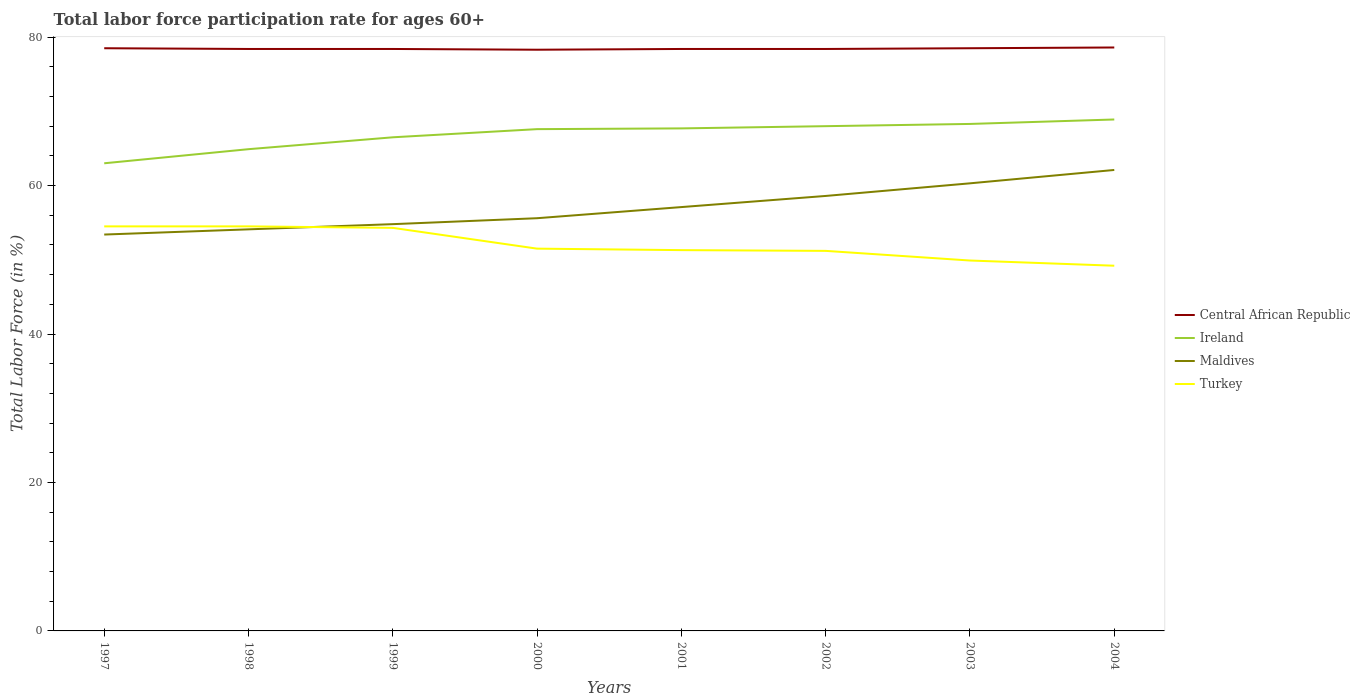How many different coloured lines are there?
Keep it short and to the point. 4. Does the line corresponding to Maldives intersect with the line corresponding to Ireland?
Ensure brevity in your answer.  No. Across all years, what is the maximum labor force participation rate in Ireland?
Your answer should be compact. 63. What is the total labor force participation rate in Ireland in the graph?
Your answer should be compact. -2.7. What is the difference between the highest and the second highest labor force participation rate in Ireland?
Offer a terse response. 5.9. How many years are there in the graph?
Ensure brevity in your answer.  8. What is the difference between two consecutive major ticks on the Y-axis?
Your response must be concise. 20. Are the values on the major ticks of Y-axis written in scientific E-notation?
Make the answer very short. No. Does the graph contain any zero values?
Keep it short and to the point. No. Where does the legend appear in the graph?
Your answer should be very brief. Center right. How many legend labels are there?
Your answer should be very brief. 4. How are the legend labels stacked?
Offer a terse response. Vertical. What is the title of the graph?
Your response must be concise. Total labor force participation rate for ages 60+. Does "Iran" appear as one of the legend labels in the graph?
Provide a succinct answer. No. What is the Total Labor Force (in %) of Central African Republic in 1997?
Give a very brief answer. 78.5. What is the Total Labor Force (in %) in Maldives in 1997?
Keep it short and to the point. 53.4. What is the Total Labor Force (in %) of Turkey in 1997?
Make the answer very short. 54.5. What is the Total Labor Force (in %) of Central African Republic in 1998?
Offer a terse response. 78.4. What is the Total Labor Force (in %) in Ireland in 1998?
Offer a terse response. 64.9. What is the Total Labor Force (in %) of Maldives in 1998?
Your answer should be compact. 54.1. What is the Total Labor Force (in %) of Turkey in 1998?
Keep it short and to the point. 54.5. What is the Total Labor Force (in %) of Central African Republic in 1999?
Keep it short and to the point. 78.4. What is the Total Labor Force (in %) of Ireland in 1999?
Make the answer very short. 66.5. What is the Total Labor Force (in %) of Maldives in 1999?
Give a very brief answer. 54.8. What is the Total Labor Force (in %) of Turkey in 1999?
Your answer should be compact. 54.3. What is the Total Labor Force (in %) of Central African Republic in 2000?
Provide a succinct answer. 78.3. What is the Total Labor Force (in %) in Ireland in 2000?
Offer a very short reply. 67.6. What is the Total Labor Force (in %) in Maldives in 2000?
Ensure brevity in your answer.  55.6. What is the Total Labor Force (in %) of Turkey in 2000?
Give a very brief answer. 51.5. What is the Total Labor Force (in %) in Central African Republic in 2001?
Keep it short and to the point. 78.4. What is the Total Labor Force (in %) in Ireland in 2001?
Make the answer very short. 67.7. What is the Total Labor Force (in %) of Maldives in 2001?
Give a very brief answer. 57.1. What is the Total Labor Force (in %) in Turkey in 2001?
Your response must be concise. 51.3. What is the Total Labor Force (in %) in Central African Republic in 2002?
Keep it short and to the point. 78.4. What is the Total Labor Force (in %) of Maldives in 2002?
Offer a very short reply. 58.6. What is the Total Labor Force (in %) of Turkey in 2002?
Give a very brief answer. 51.2. What is the Total Labor Force (in %) in Central African Republic in 2003?
Make the answer very short. 78.5. What is the Total Labor Force (in %) of Ireland in 2003?
Offer a very short reply. 68.3. What is the Total Labor Force (in %) in Maldives in 2003?
Provide a succinct answer. 60.3. What is the Total Labor Force (in %) in Turkey in 2003?
Your response must be concise. 49.9. What is the Total Labor Force (in %) of Central African Republic in 2004?
Give a very brief answer. 78.6. What is the Total Labor Force (in %) in Ireland in 2004?
Your response must be concise. 68.9. What is the Total Labor Force (in %) in Maldives in 2004?
Provide a short and direct response. 62.1. What is the Total Labor Force (in %) of Turkey in 2004?
Keep it short and to the point. 49.2. Across all years, what is the maximum Total Labor Force (in %) in Central African Republic?
Offer a terse response. 78.6. Across all years, what is the maximum Total Labor Force (in %) in Ireland?
Offer a terse response. 68.9. Across all years, what is the maximum Total Labor Force (in %) in Maldives?
Provide a succinct answer. 62.1. Across all years, what is the maximum Total Labor Force (in %) in Turkey?
Ensure brevity in your answer.  54.5. Across all years, what is the minimum Total Labor Force (in %) of Central African Republic?
Provide a succinct answer. 78.3. Across all years, what is the minimum Total Labor Force (in %) of Ireland?
Make the answer very short. 63. Across all years, what is the minimum Total Labor Force (in %) in Maldives?
Make the answer very short. 53.4. Across all years, what is the minimum Total Labor Force (in %) in Turkey?
Offer a very short reply. 49.2. What is the total Total Labor Force (in %) of Central African Republic in the graph?
Keep it short and to the point. 627.5. What is the total Total Labor Force (in %) in Ireland in the graph?
Make the answer very short. 534.9. What is the total Total Labor Force (in %) in Maldives in the graph?
Give a very brief answer. 456. What is the total Total Labor Force (in %) of Turkey in the graph?
Provide a short and direct response. 416.4. What is the difference between the Total Labor Force (in %) in Maldives in 1997 and that in 1998?
Ensure brevity in your answer.  -0.7. What is the difference between the Total Labor Force (in %) in Turkey in 1997 and that in 1998?
Keep it short and to the point. 0. What is the difference between the Total Labor Force (in %) in Central African Republic in 1997 and that in 1999?
Your answer should be very brief. 0.1. What is the difference between the Total Labor Force (in %) of Ireland in 1997 and that in 1999?
Provide a short and direct response. -3.5. What is the difference between the Total Labor Force (in %) in Turkey in 1997 and that in 1999?
Give a very brief answer. 0.2. What is the difference between the Total Labor Force (in %) in Central African Republic in 1997 and that in 2000?
Your response must be concise. 0.2. What is the difference between the Total Labor Force (in %) in Maldives in 1997 and that in 2000?
Your answer should be compact. -2.2. What is the difference between the Total Labor Force (in %) in Central African Republic in 1997 and that in 2001?
Provide a succinct answer. 0.1. What is the difference between the Total Labor Force (in %) of Ireland in 1997 and that in 2001?
Your answer should be very brief. -4.7. What is the difference between the Total Labor Force (in %) in Maldives in 1997 and that in 2001?
Your response must be concise. -3.7. What is the difference between the Total Labor Force (in %) in Turkey in 1997 and that in 2001?
Ensure brevity in your answer.  3.2. What is the difference between the Total Labor Force (in %) in Central African Republic in 1997 and that in 2002?
Ensure brevity in your answer.  0.1. What is the difference between the Total Labor Force (in %) in Ireland in 1997 and that in 2002?
Give a very brief answer. -5. What is the difference between the Total Labor Force (in %) in Turkey in 1997 and that in 2002?
Provide a short and direct response. 3.3. What is the difference between the Total Labor Force (in %) of Ireland in 1997 and that in 2003?
Ensure brevity in your answer.  -5.3. What is the difference between the Total Labor Force (in %) in Maldives in 1997 and that in 2003?
Offer a very short reply. -6.9. What is the difference between the Total Labor Force (in %) in Ireland in 1997 and that in 2004?
Give a very brief answer. -5.9. What is the difference between the Total Labor Force (in %) in Maldives in 1997 and that in 2004?
Offer a terse response. -8.7. What is the difference between the Total Labor Force (in %) of Turkey in 1997 and that in 2004?
Ensure brevity in your answer.  5.3. What is the difference between the Total Labor Force (in %) of Turkey in 1998 and that in 1999?
Offer a very short reply. 0.2. What is the difference between the Total Labor Force (in %) of Central African Republic in 1998 and that in 2000?
Offer a terse response. 0.1. What is the difference between the Total Labor Force (in %) of Ireland in 1998 and that in 2000?
Keep it short and to the point. -2.7. What is the difference between the Total Labor Force (in %) of Turkey in 1998 and that in 2000?
Offer a terse response. 3. What is the difference between the Total Labor Force (in %) of Central African Republic in 1998 and that in 2001?
Provide a succinct answer. 0. What is the difference between the Total Labor Force (in %) in Maldives in 1998 and that in 2001?
Your answer should be very brief. -3. What is the difference between the Total Labor Force (in %) of Turkey in 1998 and that in 2001?
Your response must be concise. 3.2. What is the difference between the Total Labor Force (in %) in Central African Republic in 1998 and that in 2002?
Give a very brief answer. 0. What is the difference between the Total Labor Force (in %) in Maldives in 1998 and that in 2002?
Ensure brevity in your answer.  -4.5. What is the difference between the Total Labor Force (in %) in Turkey in 1998 and that in 2002?
Your answer should be compact. 3.3. What is the difference between the Total Labor Force (in %) of Central African Republic in 1998 and that in 2003?
Your response must be concise. -0.1. What is the difference between the Total Labor Force (in %) of Turkey in 1998 and that in 2003?
Keep it short and to the point. 4.6. What is the difference between the Total Labor Force (in %) of Ireland in 1998 and that in 2004?
Provide a succinct answer. -4. What is the difference between the Total Labor Force (in %) of Turkey in 1998 and that in 2004?
Provide a short and direct response. 5.3. What is the difference between the Total Labor Force (in %) of Ireland in 1999 and that in 2000?
Your answer should be compact. -1.1. What is the difference between the Total Labor Force (in %) of Maldives in 1999 and that in 2000?
Provide a succinct answer. -0.8. What is the difference between the Total Labor Force (in %) in Ireland in 1999 and that in 2002?
Offer a very short reply. -1.5. What is the difference between the Total Labor Force (in %) of Maldives in 1999 and that in 2002?
Offer a terse response. -3.8. What is the difference between the Total Labor Force (in %) in Turkey in 1999 and that in 2002?
Offer a terse response. 3.1. What is the difference between the Total Labor Force (in %) of Central African Republic in 1999 and that in 2003?
Offer a very short reply. -0.1. What is the difference between the Total Labor Force (in %) in Ireland in 1999 and that in 2003?
Your answer should be compact. -1.8. What is the difference between the Total Labor Force (in %) of Turkey in 1999 and that in 2003?
Keep it short and to the point. 4.4. What is the difference between the Total Labor Force (in %) of Ireland in 2000 and that in 2001?
Provide a short and direct response. -0.1. What is the difference between the Total Labor Force (in %) of Maldives in 2000 and that in 2001?
Provide a short and direct response. -1.5. What is the difference between the Total Labor Force (in %) in Turkey in 2000 and that in 2002?
Offer a very short reply. 0.3. What is the difference between the Total Labor Force (in %) in Maldives in 2000 and that in 2003?
Offer a terse response. -4.7. What is the difference between the Total Labor Force (in %) in Ireland in 2000 and that in 2004?
Your answer should be compact. -1.3. What is the difference between the Total Labor Force (in %) of Turkey in 2000 and that in 2004?
Provide a short and direct response. 2.3. What is the difference between the Total Labor Force (in %) of Central African Republic in 2001 and that in 2002?
Provide a short and direct response. 0. What is the difference between the Total Labor Force (in %) of Ireland in 2001 and that in 2002?
Offer a very short reply. -0.3. What is the difference between the Total Labor Force (in %) of Maldives in 2001 and that in 2002?
Your response must be concise. -1.5. What is the difference between the Total Labor Force (in %) in Ireland in 2001 and that in 2003?
Keep it short and to the point. -0.6. What is the difference between the Total Labor Force (in %) of Ireland in 2001 and that in 2004?
Keep it short and to the point. -1.2. What is the difference between the Total Labor Force (in %) of Turkey in 2001 and that in 2004?
Offer a very short reply. 2.1. What is the difference between the Total Labor Force (in %) in Central African Republic in 2002 and that in 2003?
Ensure brevity in your answer.  -0.1. What is the difference between the Total Labor Force (in %) in Ireland in 2002 and that in 2003?
Provide a short and direct response. -0.3. What is the difference between the Total Labor Force (in %) of Maldives in 2002 and that in 2003?
Offer a very short reply. -1.7. What is the difference between the Total Labor Force (in %) in Ireland in 2002 and that in 2004?
Ensure brevity in your answer.  -0.9. What is the difference between the Total Labor Force (in %) in Ireland in 2003 and that in 2004?
Ensure brevity in your answer.  -0.6. What is the difference between the Total Labor Force (in %) in Maldives in 2003 and that in 2004?
Provide a short and direct response. -1.8. What is the difference between the Total Labor Force (in %) of Central African Republic in 1997 and the Total Labor Force (in %) of Maldives in 1998?
Offer a terse response. 24.4. What is the difference between the Total Labor Force (in %) in Ireland in 1997 and the Total Labor Force (in %) in Maldives in 1998?
Keep it short and to the point. 8.9. What is the difference between the Total Labor Force (in %) in Ireland in 1997 and the Total Labor Force (in %) in Turkey in 1998?
Your answer should be very brief. 8.5. What is the difference between the Total Labor Force (in %) in Maldives in 1997 and the Total Labor Force (in %) in Turkey in 1998?
Give a very brief answer. -1.1. What is the difference between the Total Labor Force (in %) in Central African Republic in 1997 and the Total Labor Force (in %) in Maldives in 1999?
Provide a short and direct response. 23.7. What is the difference between the Total Labor Force (in %) in Central African Republic in 1997 and the Total Labor Force (in %) in Turkey in 1999?
Ensure brevity in your answer.  24.2. What is the difference between the Total Labor Force (in %) in Ireland in 1997 and the Total Labor Force (in %) in Turkey in 1999?
Your response must be concise. 8.7. What is the difference between the Total Labor Force (in %) in Central African Republic in 1997 and the Total Labor Force (in %) in Ireland in 2000?
Your answer should be compact. 10.9. What is the difference between the Total Labor Force (in %) of Central African Republic in 1997 and the Total Labor Force (in %) of Maldives in 2000?
Ensure brevity in your answer.  22.9. What is the difference between the Total Labor Force (in %) in Central African Republic in 1997 and the Total Labor Force (in %) in Turkey in 2000?
Ensure brevity in your answer.  27. What is the difference between the Total Labor Force (in %) in Maldives in 1997 and the Total Labor Force (in %) in Turkey in 2000?
Make the answer very short. 1.9. What is the difference between the Total Labor Force (in %) in Central African Republic in 1997 and the Total Labor Force (in %) in Maldives in 2001?
Provide a succinct answer. 21.4. What is the difference between the Total Labor Force (in %) in Central African Republic in 1997 and the Total Labor Force (in %) in Turkey in 2001?
Offer a very short reply. 27.2. What is the difference between the Total Labor Force (in %) in Ireland in 1997 and the Total Labor Force (in %) in Maldives in 2001?
Your response must be concise. 5.9. What is the difference between the Total Labor Force (in %) in Ireland in 1997 and the Total Labor Force (in %) in Turkey in 2001?
Ensure brevity in your answer.  11.7. What is the difference between the Total Labor Force (in %) in Central African Republic in 1997 and the Total Labor Force (in %) in Ireland in 2002?
Keep it short and to the point. 10.5. What is the difference between the Total Labor Force (in %) of Central African Republic in 1997 and the Total Labor Force (in %) of Maldives in 2002?
Keep it short and to the point. 19.9. What is the difference between the Total Labor Force (in %) in Central African Republic in 1997 and the Total Labor Force (in %) in Turkey in 2002?
Provide a short and direct response. 27.3. What is the difference between the Total Labor Force (in %) in Ireland in 1997 and the Total Labor Force (in %) in Maldives in 2002?
Make the answer very short. 4.4. What is the difference between the Total Labor Force (in %) in Ireland in 1997 and the Total Labor Force (in %) in Turkey in 2002?
Make the answer very short. 11.8. What is the difference between the Total Labor Force (in %) in Central African Republic in 1997 and the Total Labor Force (in %) in Ireland in 2003?
Your response must be concise. 10.2. What is the difference between the Total Labor Force (in %) of Central African Republic in 1997 and the Total Labor Force (in %) of Turkey in 2003?
Provide a short and direct response. 28.6. What is the difference between the Total Labor Force (in %) of Ireland in 1997 and the Total Labor Force (in %) of Maldives in 2003?
Offer a terse response. 2.7. What is the difference between the Total Labor Force (in %) of Central African Republic in 1997 and the Total Labor Force (in %) of Turkey in 2004?
Give a very brief answer. 29.3. What is the difference between the Total Labor Force (in %) of Ireland in 1997 and the Total Labor Force (in %) of Maldives in 2004?
Your answer should be compact. 0.9. What is the difference between the Total Labor Force (in %) of Maldives in 1997 and the Total Labor Force (in %) of Turkey in 2004?
Your answer should be very brief. 4.2. What is the difference between the Total Labor Force (in %) in Central African Republic in 1998 and the Total Labor Force (in %) in Ireland in 1999?
Ensure brevity in your answer.  11.9. What is the difference between the Total Labor Force (in %) of Central African Republic in 1998 and the Total Labor Force (in %) of Maldives in 1999?
Your answer should be very brief. 23.6. What is the difference between the Total Labor Force (in %) in Central African Republic in 1998 and the Total Labor Force (in %) in Turkey in 1999?
Your response must be concise. 24.1. What is the difference between the Total Labor Force (in %) in Maldives in 1998 and the Total Labor Force (in %) in Turkey in 1999?
Your answer should be compact. -0.2. What is the difference between the Total Labor Force (in %) in Central African Republic in 1998 and the Total Labor Force (in %) in Maldives in 2000?
Provide a short and direct response. 22.8. What is the difference between the Total Labor Force (in %) in Central African Republic in 1998 and the Total Labor Force (in %) in Turkey in 2000?
Give a very brief answer. 26.9. What is the difference between the Total Labor Force (in %) of Maldives in 1998 and the Total Labor Force (in %) of Turkey in 2000?
Keep it short and to the point. 2.6. What is the difference between the Total Labor Force (in %) of Central African Republic in 1998 and the Total Labor Force (in %) of Ireland in 2001?
Offer a very short reply. 10.7. What is the difference between the Total Labor Force (in %) in Central African Republic in 1998 and the Total Labor Force (in %) in Maldives in 2001?
Offer a very short reply. 21.3. What is the difference between the Total Labor Force (in %) in Central African Republic in 1998 and the Total Labor Force (in %) in Turkey in 2001?
Your response must be concise. 27.1. What is the difference between the Total Labor Force (in %) of Ireland in 1998 and the Total Labor Force (in %) of Maldives in 2001?
Offer a terse response. 7.8. What is the difference between the Total Labor Force (in %) in Central African Republic in 1998 and the Total Labor Force (in %) in Ireland in 2002?
Ensure brevity in your answer.  10.4. What is the difference between the Total Labor Force (in %) in Central African Republic in 1998 and the Total Labor Force (in %) in Maldives in 2002?
Your response must be concise. 19.8. What is the difference between the Total Labor Force (in %) of Central African Republic in 1998 and the Total Labor Force (in %) of Turkey in 2002?
Make the answer very short. 27.2. What is the difference between the Total Labor Force (in %) in Ireland in 1998 and the Total Labor Force (in %) in Maldives in 2002?
Your answer should be very brief. 6.3. What is the difference between the Total Labor Force (in %) of Central African Republic in 1998 and the Total Labor Force (in %) of Ireland in 2004?
Provide a succinct answer. 9.5. What is the difference between the Total Labor Force (in %) in Central African Republic in 1998 and the Total Labor Force (in %) in Maldives in 2004?
Provide a succinct answer. 16.3. What is the difference between the Total Labor Force (in %) in Central African Republic in 1998 and the Total Labor Force (in %) in Turkey in 2004?
Give a very brief answer. 29.2. What is the difference between the Total Labor Force (in %) of Ireland in 1998 and the Total Labor Force (in %) of Maldives in 2004?
Your response must be concise. 2.8. What is the difference between the Total Labor Force (in %) in Central African Republic in 1999 and the Total Labor Force (in %) in Ireland in 2000?
Provide a short and direct response. 10.8. What is the difference between the Total Labor Force (in %) in Central African Republic in 1999 and the Total Labor Force (in %) in Maldives in 2000?
Your response must be concise. 22.8. What is the difference between the Total Labor Force (in %) in Central African Republic in 1999 and the Total Labor Force (in %) in Turkey in 2000?
Your answer should be very brief. 26.9. What is the difference between the Total Labor Force (in %) of Central African Republic in 1999 and the Total Labor Force (in %) of Ireland in 2001?
Give a very brief answer. 10.7. What is the difference between the Total Labor Force (in %) in Central African Republic in 1999 and the Total Labor Force (in %) in Maldives in 2001?
Keep it short and to the point. 21.3. What is the difference between the Total Labor Force (in %) of Central African Republic in 1999 and the Total Labor Force (in %) of Turkey in 2001?
Your answer should be very brief. 27.1. What is the difference between the Total Labor Force (in %) of Ireland in 1999 and the Total Labor Force (in %) of Turkey in 2001?
Make the answer very short. 15.2. What is the difference between the Total Labor Force (in %) in Maldives in 1999 and the Total Labor Force (in %) in Turkey in 2001?
Provide a succinct answer. 3.5. What is the difference between the Total Labor Force (in %) of Central African Republic in 1999 and the Total Labor Force (in %) of Ireland in 2002?
Offer a terse response. 10.4. What is the difference between the Total Labor Force (in %) in Central African Republic in 1999 and the Total Labor Force (in %) in Maldives in 2002?
Provide a succinct answer. 19.8. What is the difference between the Total Labor Force (in %) in Central African Republic in 1999 and the Total Labor Force (in %) in Turkey in 2002?
Your response must be concise. 27.2. What is the difference between the Total Labor Force (in %) in Ireland in 1999 and the Total Labor Force (in %) in Maldives in 2002?
Give a very brief answer. 7.9. What is the difference between the Total Labor Force (in %) of Ireland in 1999 and the Total Labor Force (in %) of Turkey in 2002?
Your response must be concise. 15.3. What is the difference between the Total Labor Force (in %) in Central African Republic in 1999 and the Total Labor Force (in %) in Ireland in 2003?
Ensure brevity in your answer.  10.1. What is the difference between the Total Labor Force (in %) in Central African Republic in 1999 and the Total Labor Force (in %) in Maldives in 2003?
Your answer should be compact. 18.1. What is the difference between the Total Labor Force (in %) of Ireland in 1999 and the Total Labor Force (in %) of Maldives in 2003?
Make the answer very short. 6.2. What is the difference between the Total Labor Force (in %) in Maldives in 1999 and the Total Labor Force (in %) in Turkey in 2003?
Give a very brief answer. 4.9. What is the difference between the Total Labor Force (in %) of Central African Republic in 1999 and the Total Labor Force (in %) of Ireland in 2004?
Ensure brevity in your answer.  9.5. What is the difference between the Total Labor Force (in %) of Central African Republic in 1999 and the Total Labor Force (in %) of Turkey in 2004?
Ensure brevity in your answer.  29.2. What is the difference between the Total Labor Force (in %) in Ireland in 1999 and the Total Labor Force (in %) in Turkey in 2004?
Keep it short and to the point. 17.3. What is the difference between the Total Labor Force (in %) of Maldives in 1999 and the Total Labor Force (in %) of Turkey in 2004?
Give a very brief answer. 5.6. What is the difference between the Total Labor Force (in %) in Central African Republic in 2000 and the Total Labor Force (in %) in Maldives in 2001?
Your answer should be very brief. 21.2. What is the difference between the Total Labor Force (in %) of Central African Republic in 2000 and the Total Labor Force (in %) of Turkey in 2001?
Your answer should be very brief. 27. What is the difference between the Total Labor Force (in %) of Ireland in 2000 and the Total Labor Force (in %) of Maldives in 2001?
Your answer should be very brief. 10.5. What is the difference between the Total Labor Force (in %) of Maldives in 2000 and the Total Labor Force (in %) of Turkey in 2001?
Keep it short and to the point. 4.3. What is the difference between the Total Labor Force (in %) of Central African Republic in 2000 and the Total Labor Force (in %) of Ireland in 2002?
Keep it short and to the point. 10.3. What is the difference between the Total Labor Force (in %) of Central African Republic in 2000 and the Total Labor Force (in %) of Turkey in 2002?
Ensure brevity in your answer.  27.1. What is the difference between the Total Labor Force (in %) in Ireland in 2000 and the Total Labor Force (in %) in Maldives in 2002?
Give a very brief answer. 9. What is the difference between the Total Labor Force (in %) of Ireland in 2000 and the Total Labor Force (in %) of Turkey in 2002?
Make the answer very short. 16.4. What is the difference between the Total Labor Force (in %) of Maldives in 2000 and the Total Labor Force (in %) of Turkey in 2002?
Provide a short and direct response. 4.4. What is the difference between the Total Labor Force (in %) in Central African Republic in 2000 and the Total Labor Force (in %) in Turkey in 2003?
Offer a very short reply. 28.4. What is the difference between the Total Labor Force (in %) of Ireland in 2000 and the Total Labor Force (in %) of Maldives in 2003?
Make the answer very short. 7.3. What is the difference between the Total Labor Force (in %) of Maldives in 2000 and the Total Labor Force (in %) of Turkey in 2003?
Keep it short and to the point. 5.7. What is the difference between the Total Labor Force (in %) of Central African Republic in 2000 and the Total Labor Force (in %) of Maldives in 2004?
Provide a succinct answer. 16.2. What is the difference between the Total Labor Force (in %) in Central African Republic in 2000 and the Total Labor Force (in %) in Turkey in 2004?
Provide a succinct answer. 29.1. What is the difference between the Total Labor Force (in %) in Ireland in 2000 and the Total Labor Force (in %) in Maldives in 2004?
Your answer should be compact. 5.5. What is the difference between the Total Labor Force (in %) of Ireland in 2000 and the Total Labor Force (in %) of Turkey in 2004?
Keep it short and to the point. 18.4. What is the difference between the Total Labor Force (in %) of Maldives in 2000 and the Total Labor Force (in %) of Turkey in 2004?
Ensure brevity in your answer.  6.4. What is the difference between the Total Labor Force (in %) in Central African Republic in 2001 and the Total Labor Force (in %) in Ireland in 2002?
Offer a terse response. 10.4. What is the difference between the Total Labor Force (in %) of Central African Republic in 2001 and the Total Labor Force (in %) of Maldives in 2002?
Offer a very short reply. 19.8. What is the difference between the Total Labor Force (in %) in Central African Republic in 2001 and the Total Labor Force (in %) in Turkey in 2002?
Offer a very short reply. 27.2. What is the difference between the Total Labor Force (in %) in Ireland in 2001 and the Total Labor Force (in %) in Turkey in 2002?
Provide a succinct answer. 16.5. What is the difference between the Total Labor Force (in %) of Central African Republic in 2001 and the Total Labor Force (in %) of Ireland in 2003?
Make the answer very short. 10.1. What is the difference between the Total Labor Force (in %) of Central African Republic in 2001 and the Total Labor Force (in %) of Turkey in 2003?
Your answer should be very brief. 28.5. What is the difference between the Total Labor Force (in %) of Ireland in 2001 and the Total Labor Force (in %) of Maldives in 2003?
Provide a short and direct response. 7.4. What is the difference between the Total Labor Force (in %) of Maldives in 2001 and the Total Labor Force (in %) of Turkey in 2003?
Your response must be concise. 7.2. What is the difference between the Total Labor Force (in %) of Central African Republic in 2001 and the Total Labor Force (in %) of Maldives in 2004?
Give a very brief answer. 16.3. What is the difference between the Total Labor Force (in %) in Central African Republic in 2001 and the Total Labor Force (in %) in Turkey in 2004?
Your answer should be very brief. 29.2. What is the difference between the Total Labor Force (in %) in Ireland in 2001 and the Total Labor Force (in %) in Maldives in 2004?
Your response must be concise. 5.6. What is the difference between the Total Labor Force (in %) of Ireland in 2001 and the Total Labor Force (in %) of Turkey in 2004?
Keep it short and to the point. 18.5. What is the difference between the Total Labor Force (in %) of Central African Republic in 2002 and the Total Labor Force (in %) of Ireland in 2003?
Keep it short and to the point. 10.1. What is the difference between the Total Labor Force (in %) of Central African Republic in 2002 and the Total Labor Force (in %) of Maldives in 2003?
Give a very brief answer. 18.1. What is the difference between the Total Labor Force (in %) of Central African Republic in 2002 and the Total Labor Force (in %) of Turkey in 2003?
Make the answer very short. 28.5. What is the difference between the Total Labor Force (in %) of Ireland in 2002 and the Total Labor Force (in %) of Maldives in 2003?
Provide a succinct answer. 7.7. What is the difference between the Total Labor Force (in %) of Ireland in 2002 and the Total Labor Force (in %) of Turkey in 2003?
Keep it short and to the point. 18.1. What is the difference between the Total Labor Force (in %) of Central African Republic in 2002 and the Total Labor Force (in %) of Ireland in 2004?
Your response must be concise. 9.5. What is the difference between the Total Labor Force (in %) of Central African Republic in 2002 and the Total Labor Force (in %) of Maldives in 2004?
Provide a succinct answer. 16.3. What is the difference between the Total Labor Force (in %) of Central African Republic in 2002 and the Total Labor Force (in %) of Turkey in 2004?
Offer a terse response. 29.2. What is the difference between the Total Labor Force (in %) of Ireland in 2002 and the Total Labor Force (in %) of Turkey in 2004?
Provide a short and direct response. 18.8. What is the difference between the Total Labor Force (in %) in Maldives in 2002 and the Total Labor Force (in %) in Turkey in 2004?
Your answer should be compact. 9.4. What is the difference between the Total Labor Force (in %) in Central African Republic in 2003 and the Total Labor Force (in %) in Maldives in 2004?
Make the answer very short. 16.4. What is the difference between the Total Labor Force (in %) in Central African Republic in 2003 and the Total Labor Force (in %) in Turkey in 2004?
Your response must be concise. 29.3. What is the difference between the Total Labor Force (in %) in Ireland in 2003 and the Total Labor Force (in %) in Maldives in 2004?
Provide a succinct answer. 6.2. What is the difference between the Total Labor Force (in %) in Ireland in 2003 and the Total Labor Force (in %) in Turkey in 2004?
Keep it short and to the point. 19.1. What is the average Total Labor Force (in %) of Central African Republic per year?
Provide a short and direct response. 78.44. What is the average Total Labor Force (in %) of Ireland per year?
Make the answer very short. 66.86. What is the average Total Labor Force (in %) of Turkey per year?
Your response must be concise. 52.05. In the year 1997, what is the difference between the Total Labor Force (in %) of Central African Republic and Total Labor Force (in %) of Ireland?
Keep it short and to the point. 15.5. In the year 1997, what is the difference between the Total Labor Force (in %) in Central African Republic and Total Labor Force (in %) in Maldives?
Your answer should be very brief. 25.1. In the year 1997, what is the difference between the Total Labor Force (in %) in Central African Republic and Total Labor Force (in %) in Turkey?
Your answer should be compact. 24. In the year 1997, what is the difference between the Total Labor Force (in %) in Ireland and Total Labor Force (in %) in Turkey?
Ensure brevity in your answer.  8.5. In the year 1997, what is the difference between the Total Labor Force (in %) of Maldives and Total Labor Force (in %) of Turkey?
Ensure brevity in your answer.  -1.1. In the year 1998, what is the difference between the Total Labor Force (in %) of Central African Republic and Total Labor Force (in %) of Maldives?
Your answer should be compact. 24.3. In the year 1998, what is the difference between the Total Labor Force (in %) of Central African Republic and Total Labor Force (in %) of Turkey?
Your answer should be very brief. 23.9. In the year 1998, what is the difference between the Total Labor Force (in %) of Ireland and Total Labor Force (in %) of Turkey?
Keep it short and to the point. 10.4. In the year 1999, what is the difference between the Total Labor Force (in %) of Central African Republic and Total Labor Force (in %) of Ireland?
Provide a short and direct response. 11.9. In the year 1999, what is the difference between the Total Labor Force (in %) of Central African Republic and Total Labor Force (in %) of Maldives?
Your answer should be very brief. 23.6. In the year 1999, what is the difference between the Total Labor Force (in %) of Central African Republic and Total Labor Force (in %) of Turkey?
Your response must be concise. 24.1. In the year 1999, what is the difference between the Total Labor Force (in %) of Ireland and Total Labor Force (in %) of Maldives?
Offer a very short reply. 11.7. In the year 2000, what is the difference between the Total Labor Force (in %) in Central African Republic and Total Labor Force (in %) in Maldives?
Offer a very short reply. 22.7. In the year 2000, what is the difference between the Total Labor Force (in %) of Central African Republic and Total Labor Force (in %) of Turkey?
Your response must be concise. 26.8. In the year 2000, what is the difference between the Total Labor Force (in %) in Ireland and Total Labor Force (in %) in Maldives?
Your answer should be compact. 12. In the year 2000, what is the difference between the Total Labor Force (in %) in Ireland and Total Labor Force (in %) in Turkey?
Provide a succinct answer. 16.1. In the year 2000, what is the difference between the Total Labor Force (in %) in Maldives and Total Labor Force (in %) in Turkey?
Ensure brevity in your answer.  4.1. In the year 2001, what is the difference between the Total Labor Force (in %) of Central African Republic and Total Labor Force (in %) of Ireland?
Provide a short and direct response. 10.7. In the year 2001, what is the difference between the Total Labor Force (in %) in Central African Republic and Total Labor Force (in %) in Maldives?
Your answer should be very brief. 21.3. In the year 2001, what is the difference between the Total Labor Force (in %) of Central African Republic and Total Labor Force (in %) of Turkey?
Offer a very short reply. 27.1. In the year 2001, what is the difference between the Total Labor Force (in %) in Ireland and Total Labor Force (in %) in Maldives?
Your response must be concise. 10.6. In the year 2002, what is the difference between the Total Labor Force (in %) in Central African Republic and Total Labor Force (in %) in Maldives?
Give a very brief answer. 19.8. In the year 2002, what is the difference between the Total Labor Force (in %) of Central African Republic and Total Labor Force (in %) of Turkey?
Provide a succinct answer. 27.2. In the year 2002, what is the difference between the Total Labor Force (in %) in Maldives and Total Labor Force (in %) in Turkey?
Your answer should be very brief. 7.4. In the year 2003, what is the difference between the Total Labor Force (in %) of Central African Republic and Total Labor Force (in %) of Turkey?
Provide a succinct answer. 28.6. In the year 2004, what is the difference between the Total Labor Force (in %) in Central African Republic and Total Labor Force (in %) in Turkey?
Provide a short and direct response. 29.4. In the year 2004, what is the difference between the Total Labor Force (in %) in Ireland and Total Labor Force (in %) in Maldives?
Ensure brevity in your answer.  6.8. What is the ratio of the Total Labor Force (in %) in Ireland in 1997 to that in 1998?
Your response must be concise. 0.97. What is the ratio of the Total Labor Force (in %) of Maldives in 1997 to that in 1998?
Offer a very short reply. 0.99. What is the ratio of the Total Labor Force (in %) in Maldives in 1997 to that in 1999?
Ensure brevity in your answer.  0.97. What is the ratio of the Total Labor Force (in %) of Turkey in 1997 to that in 1999?
Your response must be concise. 1. What is the ratio of the Total Labor Force (in %) in Central African Republic in 1997 to that in 2000?
Your answer should be compact. 1. What is the ratio of the Total Labor Force (in %) in Ireland in 1997 to that in 2000?
Keep it short and to the point. 0.93. What is the ratio of the Total Labor Force (in %) of Maldives in 1997 to that in 2000?
Provide a succinct answer. 0.96. What is the ratio of the Total Labor Force (in %) in Turkey in 1997 to that in 2000?
Give a very brief answer. 1.06. What is the ratio of the Total Labor Force (in %) in Central African Republic in 1997 to that in 2001?
Provide a short and direct response. 1. What is the ratio of the Total Labor Force (in %) in Ireland in 1997 to that in 2001?
Provide a succinct answer. 0.93. What is the ratio of the Total Labor Force (in %) in Maldives in 1997 to that in 2001?
Offer a terse response. 0.94. What is the ratio of the Total Labor Force (in %) of Turkey in 1997 to that in 2001?
Provide a succinct answer. 1.06. What is the ratio of the Total Labor Force (in %) in Ireland in 1997 to that in 2002?
Your response must be concise. 0.93. What is the ratio of the Total Labor Force (in %) in Maldives in 1997 to that in 2002?
Your response must be concise. 0.91. What is the ratio of the Total Labor Force (in %) in Turkey in 1997 to that in 2002?
Give a very brief answer. 1.06. What is the ratio of the Total Labor Force (in %) of Central African Republic in 1997 to that in 2003?
Your response must be concise. 1. What is the ratio of the Total Labor Force (in %) in Ireland in 1997 to that in 2003?
Your response must be concise. 0.92. What is the ratio of the Total Labor Force (in %) in Maldives in 1997 to that in 2003?
Your answer should be very brief. 0.89. What is the ratio of the Total Labor Force (in %) in Turkey in 1997 to that in 2003?
Give a very brief answer. 1.09. What is the ratio of the Total Labor Force (in %) of Ireland in 1997 to that in 2004?
Give a very brief answer. 0.91. What is the ratio of the Total Labor Force (in %) in Maldives in 1997 to that in 2004?
Make the answer very short. 0.86. What is the ratio of the Total Labor Force (in %) in Turkey in 1997 to that in 2004?
Ensure brevity in your answer.  1.11. What is the ratio of the Total Labor Force (in %) of Central African Republic in 1998 to that in 1999?
Your response must be concise. 1. What is the ratio of the Total Labor Force (in %) in Ireland in 1998 to that in 1999?
Your answer should be compact. 0.98. What is the ratio of the Total Labor Force (in %) of Maldives in 1998 to that in 1999?
Keep it short and to the point. 0.99. What is the ratio of the Total Labor Force (in %) of Central African Republic in 1998 to that in 2000?
Keep it short and to the point. 1. What is the ratio of the Total Labor Force (in %) of Ireland in 1998 to that in 2000?
Provide a short and direct response. 0.96. What is the ratio of the Total Labor Force (in %) in Turkey in 1998 to that in 2000?
Your response must be concise. 1.06. What is the ratio of the Total Labor Force (in %) of Central African Republic in 1998 to that in 2001?
Keep it short and to the point. 1. What is the ratio of the Total Labor Force (in %) in Ireland in 1998 to that in 2001?
Give a very brief answer. 0.96. What is the ratio of the Total Labor Force (in %) in Maldives in 1998 to that in 2001?
Your response must be concise. 0.95. What is the ratio of the Total Labor Force (in %) in Turkey in 1998 to that in 2001?
Provide a short and direct response. 1.06. What is the ratio of the Total Labor Force (in %) of Ireland in 1998 to that in 2002?
Give a very brief answer. 0.95. What is the ratio of the Total Labor Force (in %) of Maldives in 1998 to that in 2002?
Keep it short and to the point. 0.92. What is the ratio of the Total Labor Force (in %) of Turkey in 1998 to that in 2002?
Offer a very short reply. 1.06. What is the ratio of the Total Labor Force (in %) in Ireland in 1998 to that in 2003?
Offer a very short reply. 0.95. What is the ratio of the Total Labor Force (in %) in Maldives in 1998 to that in 2003?
Your response must be concise. 0.9. What is the ratio of the Total Labor Force (in %) in Turkey in 1998 to that in 2003?
Your answer should be compact. 1.09. What is the ratio of the Total Labor Force (in %) in Ireland in 1998 to that in 2004?
Provide a short and direct response. 0.94. What is the ratio of the Total Labor Force (in %) in Maldives in 1998 to that in 2004?
Keep it short and to the point. 0.87. What is the ratio of the Total Labor Force (in %) of Turkey in 1998 to that in 2004?
Ensure brevity in your answer.  1.11. What is the ratio of the Total Labor Force (in %) in Ireland in 1999 to that in 2000?
Your answer should be compact. 0.98. What is the ratio of the Total Labor Force (in %) in Maldives in 1999 to that in 2000?
Keep it short and to the point. 0.99. What is the ratio of the Total Labor Force (in %) in Turkey in 1999 to that in 2000?
Ensure brevity in your answer.  1.05. What is the ratio of the Total Labor Force (in %) of Ireland in 1999 to that in 2001?
Your answer should be compact. 0.98. What is the ratio of the Total Labor Force (in %) of Maldives in 1999 to that in 2001?
Your response must be concise. 0.96. What is the ratio of the Total Labor Force (in %) in Turkey in 1999 to that in 2001?
Keep it short and to the point. 1.06. What is the ratio of the Total Labor Force (in %) of Central African Republic in 1999 to that in 2002?
Make the answer very short. 1. What is the ratio of the Total Labor Force (in %) of Ireland in 1999 to that in 2002?
Make the answer very short. 0.98. What is the ratio of the Total Labor Force (in %) of Maldives in 1999 to that in 2002?
Ensure brevity in your answer.  0.94. What is the ratio of the Total Labor Force (in %) in Turkey in 1999 to that in 2002?
Provide a short and direct response. 1.06. What is the ratio of the Total Labor Force (in %) of Central African Republic in 1999 to that in 2003?
Make the answer very short. 1. What is the ratio of the Total Labor Force (in %) in Ireland in 1999 to that in 2003?
Offer a very short reply. 0.97. What is the ratio of the Total Labor Force (in %) of Maldives in 1999 to that in 2003?
Provide a succinct answer. 0.91. What is the ratio of the Total Labor Force (in %) of Turkey in 1999 to that in 2003?
Your answer should be very brief. 1.09. What is the ratio of the Total Labor Force (in %) in Ireland in 1999 to that in 2004?
Offer a terse response. 0.97. What is the ratio of the Total Labor Force (in %) in Maldives in 1999 to that in 2004?
Give a very brief answer. 0.88. What is the ratio of the Total Labor Force (in %) in Turkey in 1999 to that in 2004?
Ensure brevity in your answer.  1.1. What is the ratio of the Total Labor Force (in %) of Ireland in 2000 to that in 2001?
Your response must be concise. 1. What is the ratio of the Total Labor Force (in %) in Maldives in 2000 to that in 2001?
Offer a terse response. 0.97. What is the ratio of the Total Labor Force (in %) in Ireland in 2000 to that in 2002?
Ensure brevity in your answer.  0.99. What is the ratio of the Total Labor Force (in %) of Maldives in 2000 to that in 2002?
Your answer should be very brief. 0.95. What is the ratio of the Total Labor Force (in %) of Turkey in 2000 to that in 2002?
Offer a terse response. 1.01. What is the ratio of the Total Labor Force (in %) in Central African Republic in 2000 to that in 2003?
Offer a terse response. 1. What is the ratio of the Total Labor Force (in %) in Maldives in 2000 to that in 2003?
Make the answer very short. 0.92. What is the ratio of the Total Labor Force (in %) of Turkey in 2000 to that in 2003?
Your answer should be very brief. 1.03. What is the ratio of the Total Labor Force (in %) in Ireland in 2000 to that in 2004?
Offer a terse response. 0.98. What is the ratio of the Total Labor Force (in %) in Maldives in 2000 to that in 2004?
Ensure brevity in your answer.  0.9. What is the ratio of the Total Labor Force (in %) in Turkey in 2000 to that in 2004?
Provide a succinct answer. 1.05. What is the ratio of the Total Labor Force (in %) in Central African Republic in 2001 to that in 2002?
Keep it short and to the point. 1. What is the ratio of the Total Labor Force (in %) in Maldives in 2001 to that in 2002?
Make the answer very short. 0.97. What is the ratio of the Total Labor Force (in %) in Maldives in 2001 to that in 2003?
Ensure brevity in your answer.  0.95. What is the ratio of the Total Labor Force (in %) of Turkey in 2001 to that in 2003?
Your answer should be very brief. 1.03. What is the ratio of the Total Labor Force (in %) in Central African Republic in 2001 to that in 2004?
Give a very brief answer. 1. What is the ratio of the Total Labor Force (in %) of Ireland in 2001 to that in 2004?
Make the answer very short. 0.98. What is the ratio of the Total Labor Force (in %) of Maldives in 2001 to that in 2004?
Your response must be concise. 0.92. What is the ratio of the Total Labor Force (in %) of Turkey in 2001 to that in 2004?
Ensure brevity in your answer.  1.04. What is the ratio of the Total Labor Force (in %) of Central African Republic in 2002 to that in 2003?
Give a very brief answer. 1. What is the ratio of the Total Labor Force (in %) of Ireland in 2002 to that in 2003?
Provide a short and direct response. 1. What is the ratio of the Total Labor Force (in %) in Maldives in 2002 to that in 2003?
Ensure brevity in your answer.  0.97. What is the ratio of the Total Labor Force (in %) in Turkey in 2002 to that in 2003?
Give a very brief answer. 1.03. What is the ratio of the Total Labor Force (in %) in Central African Republic in 2002 to that in 2004?
Your answer should be very brief. 1. What is the ratio of the Total Labor Force (in %) in Ireland in 2002 to that in 2004?
Offer a very short reply. 0.99. What is the ratio of the Total Labor Force (in %) of Maldives in 2002 to that in 2004?
Make the answer very short. 0.94. What is the ratio of the Total Labor Force (in %) of Turkey in 2002 to that in 2004?
Make the answer very short. 1.04. What is the ratio of the Total Labor Force (in %) of Ireland in 2003 to that in 2004?
Provide a succinct answer. 0.99. What is the ratio of the Total Labor Force (in %) of Turkey in 2003 to that in 2004?
Your answer should be very brief. 1.01. What is the difference between the highest and the second highest Total Labor Force (in %) of Ireland?
Offer a very short reply. 0.6. What is the difference between the highest and the second highest Total Labor Force (in %) in Maldives?
Provide a short and direct response. 1.8. What is the difference between the highest and the second highest Total Labor Force (in %) in Turkey?
Provide a succinct answer. 0. What is the difference between the highest and the lowest Total Labor Force (in %) of Central African Republic?
Offer a very short reply. 0.3. What is the difference between the highest and the lowest Total Labor Force (in %) of Ireland?
Offer a very short reply. 5.9. What is the difference between the highest and the lowest Total Labor Force (in %) of Maldives?
Your answer should be compact. 8.7. 